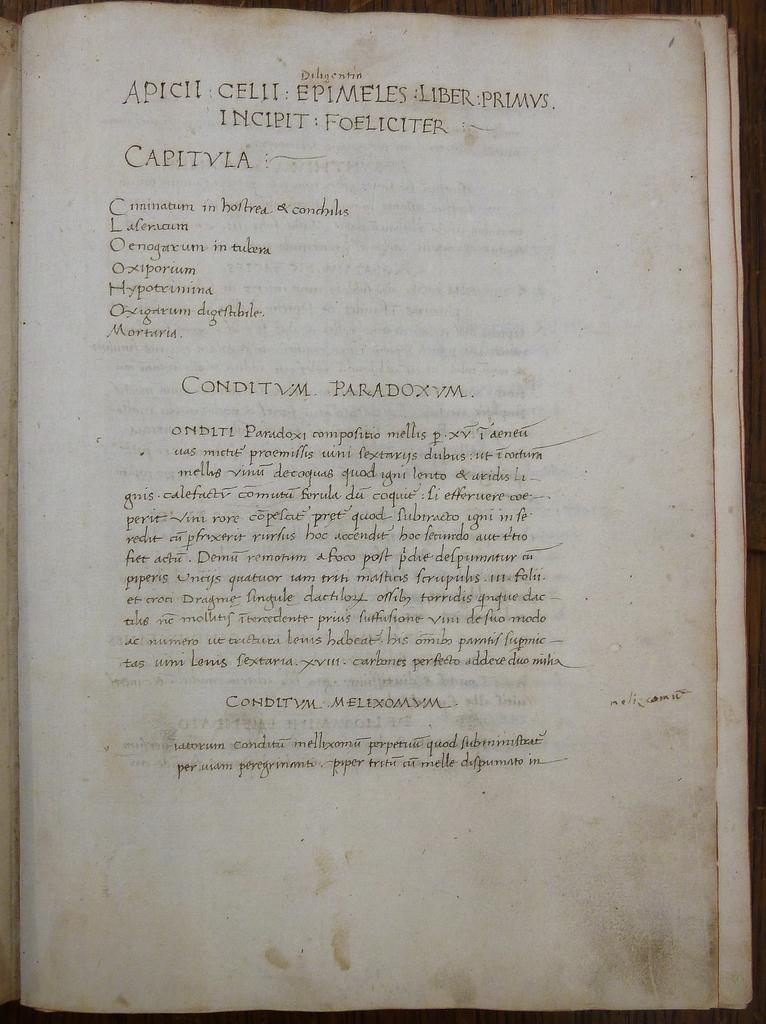What is the first word on the page?
Keep it short and to the point. Apich. What is the second word on the page?
Provide a succinct answer. Celii. 